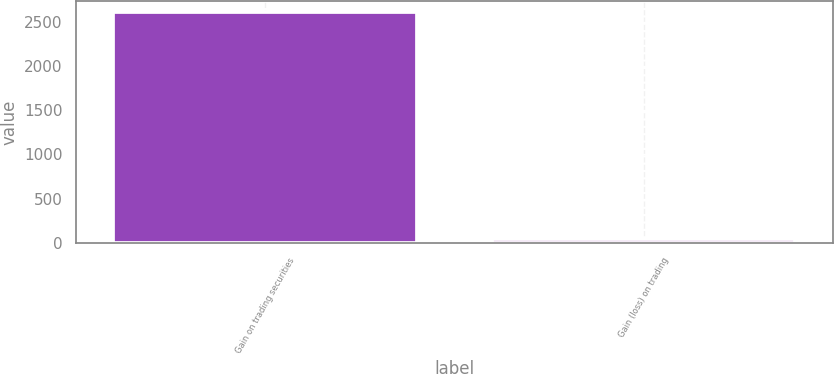Convert chart to OTSL. <chart><loc_0><loc_0><loc_500><loc_500><bar_chart><fcel>Gain on trading securities<fcel>Gain (loss) on trading<nl><fcel>2604<fcel>44<nl></chart> 